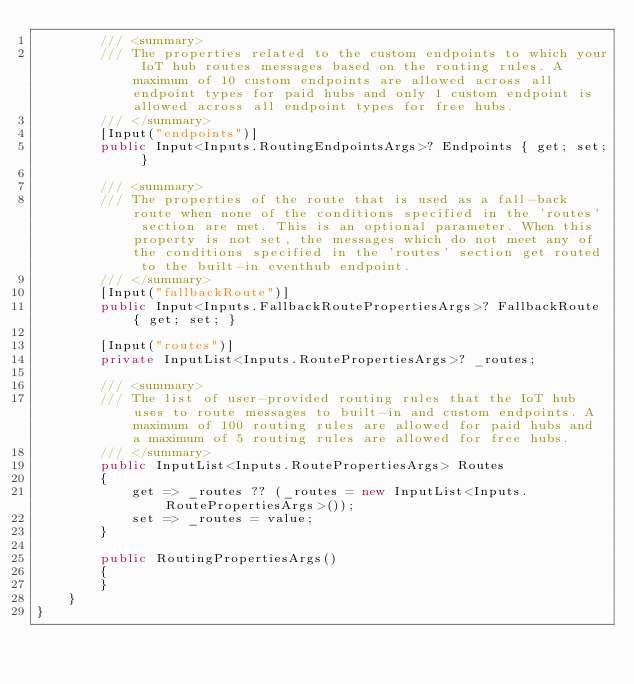<code> <loc_0><loc_0><loc_500><loc_500><_C#_>        /// <summary>
        /// The properties related to the custom endpoints to which your IoT hub routes messages based on the routing rules. A maximum of 10 custom endpoints are allowed across all endpoint types for paid hubs and only 1 custom endpoint is allowed across all endpoint types for free hubs.
        /// </summary>
        [Input("endpoints")]
        public Input<Inputs.RoutingEndpointsArgs>? Endpoints { get; set; }

        /// <summary>
        /// The properties of the route that is used as a fall-back route when none of the conditions specified in the 'routes' section are met. This is an optional parameter. When this property is not set, the messages which do not meet any of the conditions specified in the 'routes' section get routed to the built-in eventhub endpoint.
        /// </summary>
        [Input("fallbackRoute")]
        public Input<Inputs.FallbackRoutePropertiesArgs>? FallbackRoute { get; set; }

        [Input("routes")]
        private InputList<Inputs.RoutePropertiesArgs>? _routes;

        /// <summary>
        /// The list of user-provided routing rules that the IoT hub uses to route messages to built-in and custom endpoints. A maximum of 100 routing rules are allowed for paid hubs and a maximum of 5 routing rules are allowed for free hubs.
        /// </summary>
        public InputList<Inputs.RoutePropertiesArgs> Routes
        {
            get => _routes ?? (_routes = new InputList<Inputs.RoutePropertiesArgs>());
            set => _routes = value;
        }

        public RoutingPropertiesArgs()
        {
        }
    }
}
</code> 